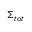Convert formula to latex. <formula><loc_0><loc_0><loc_500><loc_500>\Sigma _ { t o t }</formula> 